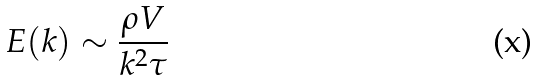Convert formula to latex. <formula><loc_0><loc_0><loc_500><loc_500>E ( k ) \sim \frac { \rho V } { k ^ { 2 } \tau }</formula> 